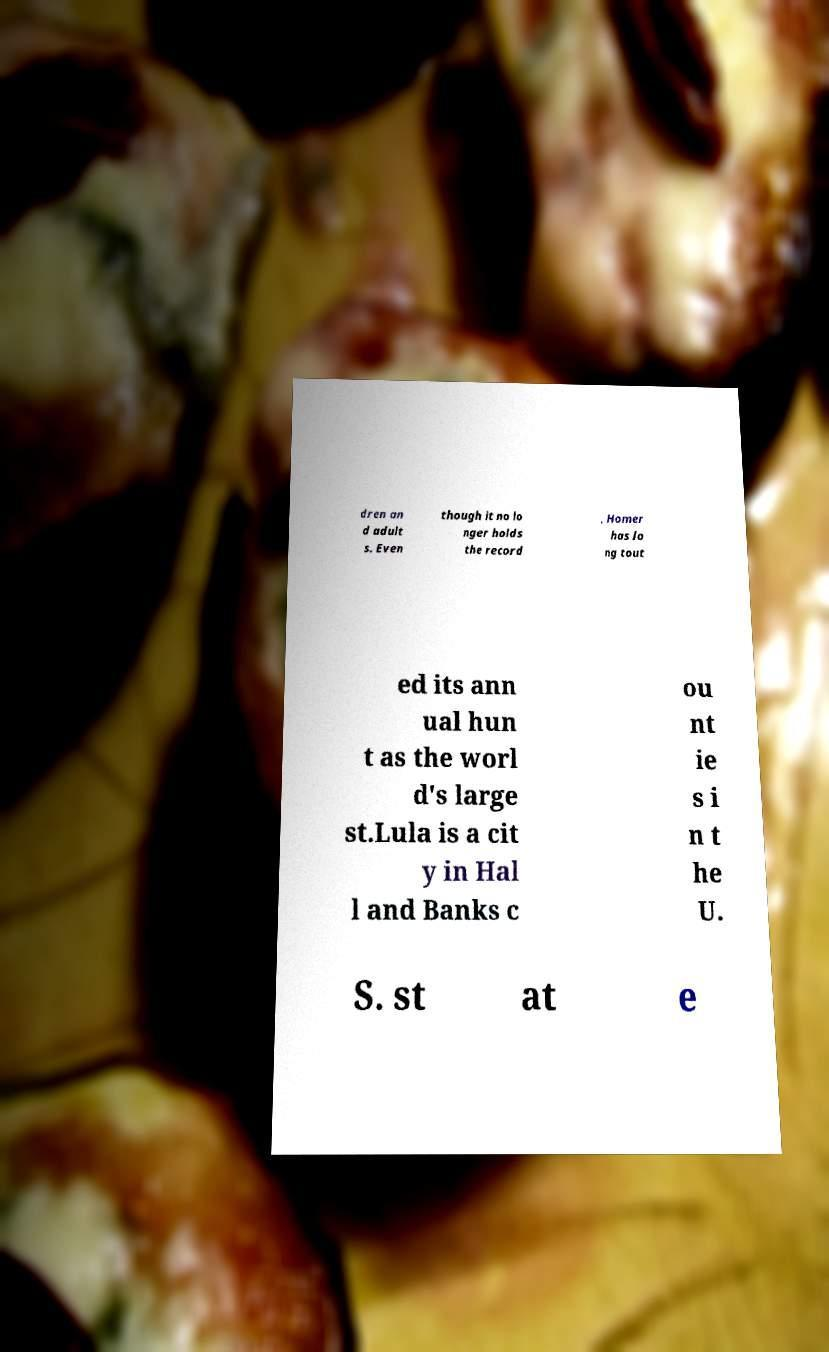Could you assist in decoding the text presented in this image and type it out clearly? dren an d adult s. Even though it no lo nger holds the record , Homer has lo ng tout ed its ann ual hun t as the worl d's large st.Lula is a cit y in Hal l and Banks c ou nt ie s i n t he U. S. st at e 